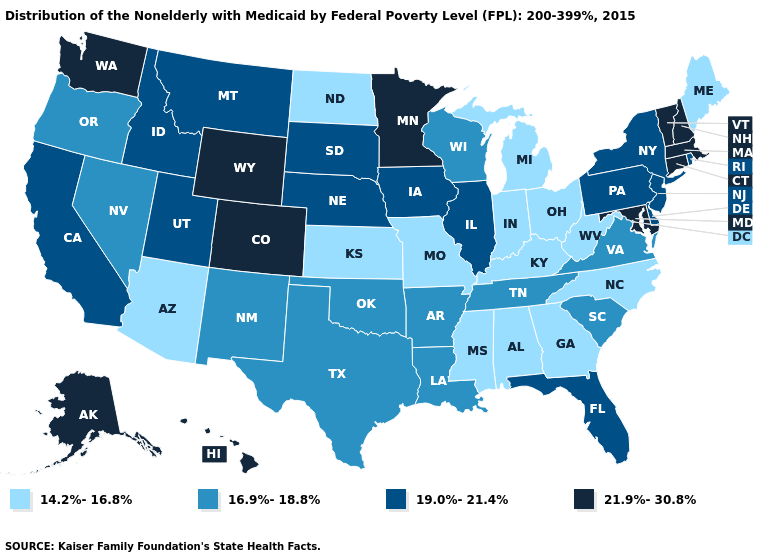What is the value of New Mexico?
Answer briefly. 16.9%-18.8%. Name the states that have a value in the range 19.0%-21.4%?
Answer briefly. California, Delaware, Florida, Idaho, Illinois, Iowa, Montana, Nebraska, New Jersey, New York, Pennsylvania, Rhode Island, South Dakota, Utah. What is the lowest value in the USA?
Quick response, please. 14.2%-16.8%. What is the lowest value in the South?
Give a very brief answer. 14.2%-16.8%. Name the states that have a value in the range 14.2%-16.8%?
Concise answer only. Alabama, Arizona, Georgia, Indiana, Kansas, Kentucky, Maine, Michigan, Mississippi, Missouri, North Carolina, North Dakota, Ohio, West Virginia. Name the states that have a value in the range 16.9%-18.8%?
Concise answer only. Arkansas, Louisiana, Nevada, New Mexico, Oklahoma, Oregon, South Carolina, Tennessee, Texas, Virginia, Wisconsin. Which states have the lowest value in the USA?
Concise answer only. Alabama, Arizona, Georgia, Indiana, Kansas, Kentucky, Maine, Michigan, Mississippi, Missouri, North Carolina, North Dakota, Ohio, West Virginia. Among the states that border Wyoming , does Colorado have the lowest value?
Short answer required. No. Does Massachusetts have the highest value in the Northeast?
Short answer required. Yes. Name the states that have a value in the range 14.2%-16.8%?
Concise answer only. Alabama, Arizona, Georgia, Indiana, Kansas, Kentucky, Maine, Michigan, Mississippi, Missouri, North Carolina, North Dakota, Ohio, West Virginia. Does Rhode Island have the lowest value in the USA?
Give a very brief answer. No. What is the value of North Dakota?
Be succinct. 14.2%-16.8%. Among the states that border Indiana , which have the highest value?
Concise answer only. Illinois. What is the value of Washington?
Give a very brief answer. 21.9%-30.8%. What is the highest value in states that border New York?
Keep it brief. 21.9%-30.8%. 